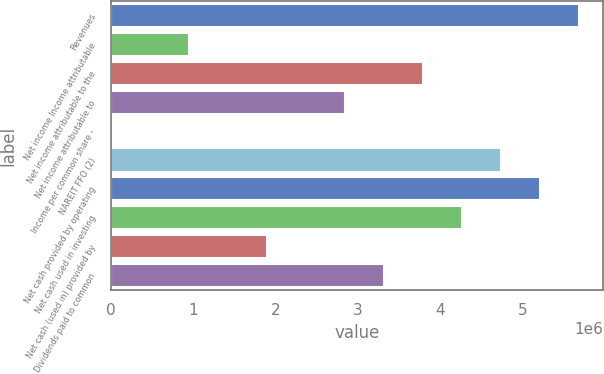Convert chart to OTSL. <chart><loc_0><loc_0><loc_500><loc_500><bar_chart><fcel>Revenues<fcel>Net income Income attributable<fcel>Net income attributable to the<fcel>Net income attributable to<fcel>Income per common share -<fcel>NAREIT FFO (2)<fcel>Net cash provided by operating<fcel>Net cash used in investing<fcel>Net cash (used in) provided by<fcel>Dividends paid to common<nl><fcel>5.69166e+06<fcel>948612<fcel>3.79444e+06<fcel>2.84583e+06<fcel>1.8<fcel>4.74305e+06<fcel>5.21736e+06<fcel>4.26875e+06<fcel>1.89722e+06<fcel>3.32014e+06<nl></chart> 